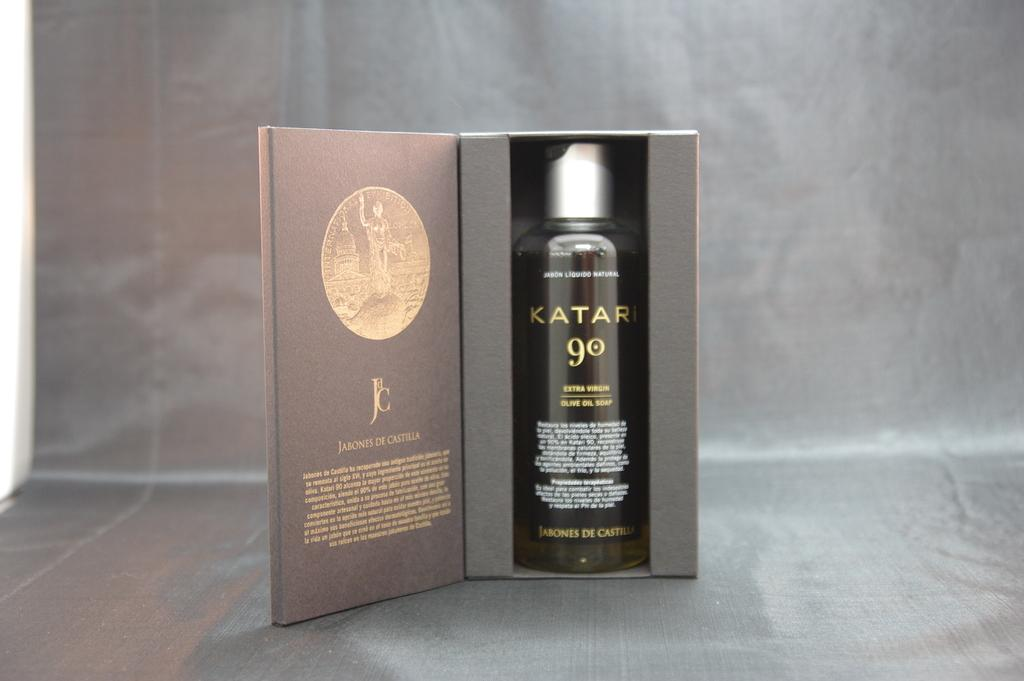<image>
Create a compact narrative representing the image presented. A bottle of Katari extra virgin olive oil soap sits in its very well designed packaging. 